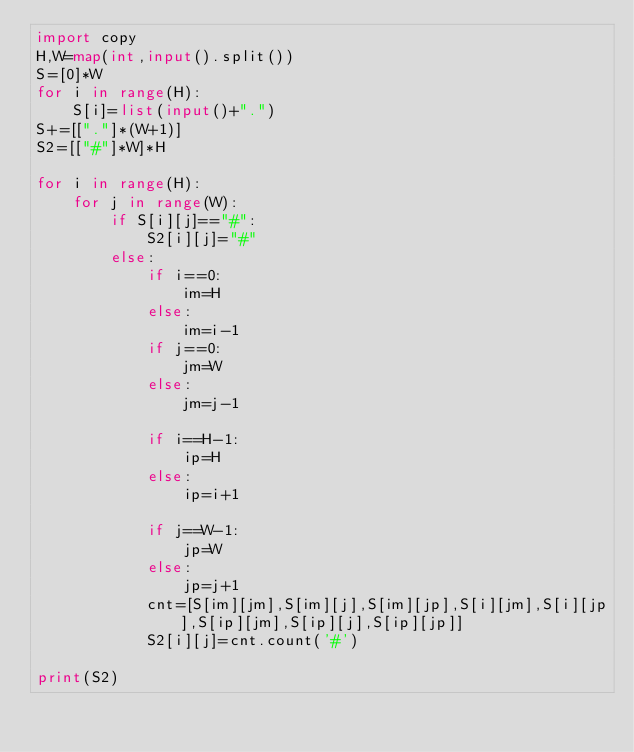<code> <loc_0><loc_0><loc_500><loc_500><_Python_>import copy
H,W=map(int,input().split())
S=[0]*W
for i in range(H):
    S[i]=list(input()+".")
S+=[["."]*(W+1)]
S2=[["#"]*W]*H

for i in range(H):
    for j in range(W):
        if S[i][j]=="#":
            S2[i][j]="#"
        else:
            if i==0:
                im=H
            else:
                im=i-1
            if j==0:
                jm=W
            else:
                jm=j-1

            if i==H-1:
                ip=H
            else:
                ip=i+1

            if j==W-1:
                jp=W
            else:
                jp=j+1
            cnt=[S[im][jm],S[im][j],S[im][jp],S[i][jm],S[i][jp],S[ip][jm],S[ip][j],S[ip][jp]]
            S2[i][j]=cnt.count('#')

print(S2)

</code> 